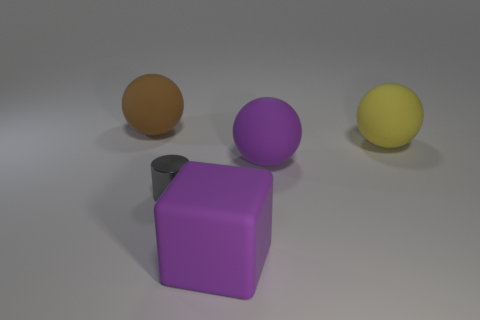Is there anything else that is the same material as the small cylinder?
Your response must be concise. No. Are there more brown rubber spheres than large rubber things?
Your response must be concise. No. What is the size of the gray cylinder in front of the large yellow sphere behind the purple object that is in front of the small gray object?
Your response must be concise. Small. There is a metal object in front of the purple sphere; what size is it?
Keep it short and to the point. Small. How many things are either large purple matte blocks or big spheres behind the big yellow sphere?
Provide a succinct answer. 2. How many other objects are the same size as the rubber block?
Offer a very short reply. 3. Is the number of things in front of the gray metallic object greater than the number of big cyan cubes?
Your response must be concise. Yes. Is there anything else that has the same color as the matte cube?
Offer a terse response. Yes. There is a large brown object that is made of the same material as the yellow sphere; what shape is it?
Offer a very short reply. Sphere. Does the sphere to the right of the purple ball have the same material as the large brown thing?
Offer a terse response. Yes. 